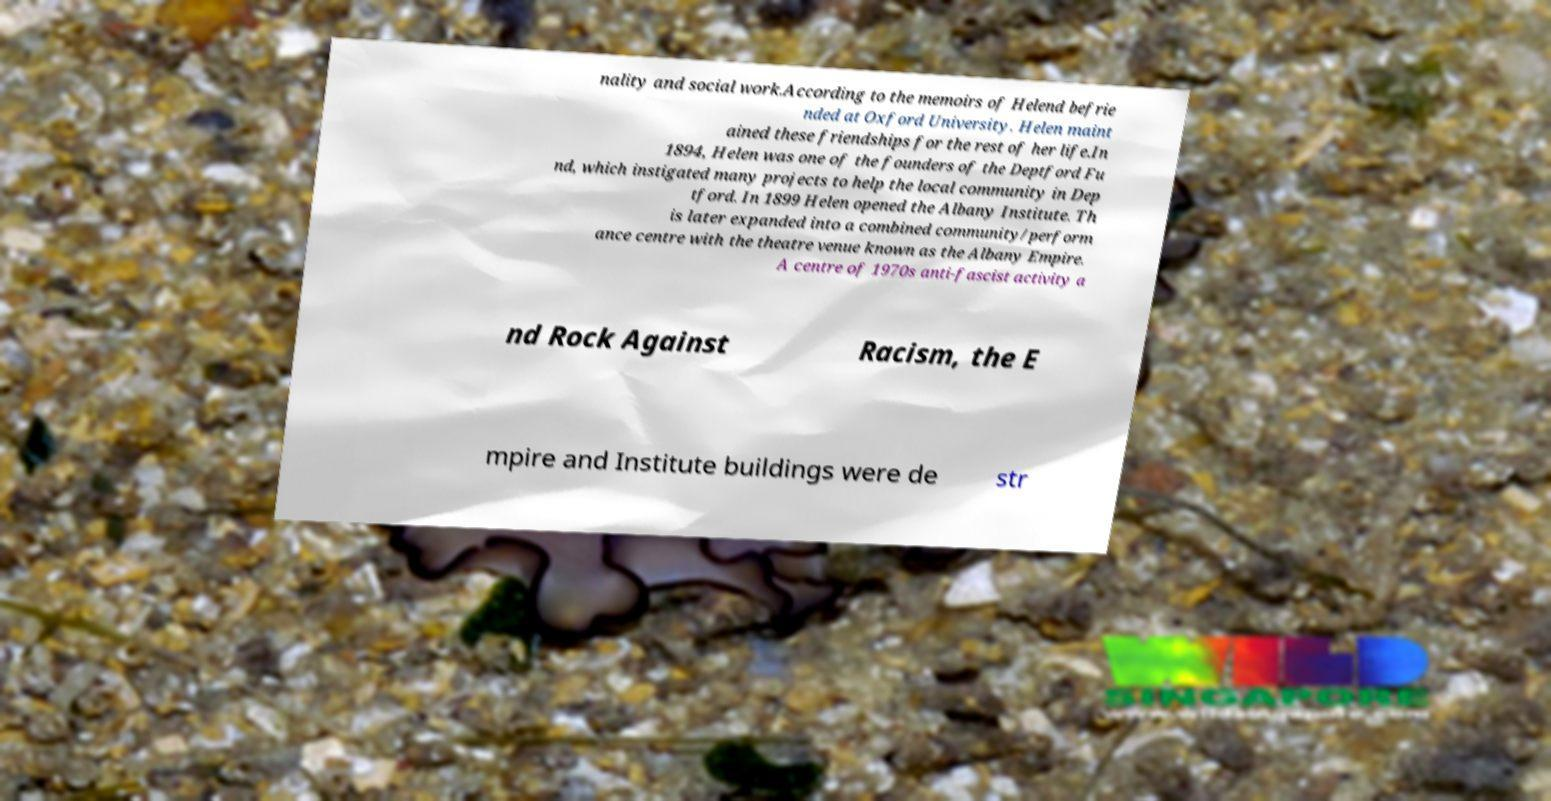Please read and relay the text visible in this image. What does it say? nality and social work.According to the memoirs of Helend befrie nded at Oxford University. Helen maint ained these friendships for the rest of her life.In 1894, Helen was one of the founders of the Deptford Fu nd, which instigated many projects to help the local community in Dep tford. In 1899 Helen opened the Albany Institute. Th is later expanded into a combined community/perform ance centre with the theatre venue known as the Albany Empire. A centre of 1970s anti-fascist activity a nd Rock Against Racism, the E mpire and Institute buildings were de str 